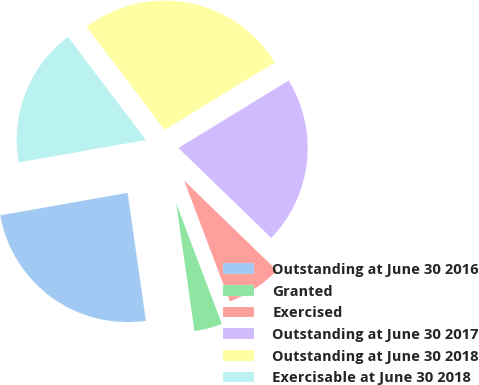Convert chart to OTSL. <chart><loc_0><loc_0><loc_500><loc_500><pie_chart><fcel>Outstanding at June 30 2016<fcel>Granted<fcel>Exercised<fcel>Outstanding at June 30 2017<fcel>Outstanding at June 30 2018<fcel>Exercisable at June 30 2018<nl><fcel>24.48%<fcel>3.5%<fcel>6.99%<fcel>20.98%<fcel>26.57%<fcel>17.48%<nl></chart> 